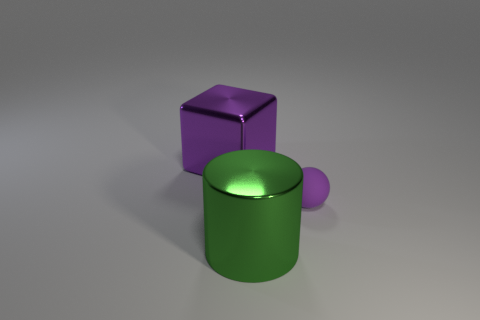What are the possible functions of these objects? The objects in the image appear to be simple geometric shapes rendering for illustrative purposes. They seem to represent a cylinder, a cube, and a sphere, commonly used in 3D modeling and computer graphics as basic components for teaching shapes, shading, and perspective. 